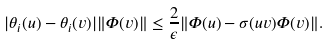<formula> <loc_0><loc_0><loc_500><loc_500>| \theta _ { i } ( u ) - \theta _ { i } ( v ) | \| \Phi ( v ) \| \leq \frac { 2 } { \epsilon } \| \Phi ( u ) - \sigma ( u v ) \Phi ( v ) \| .</formula> 